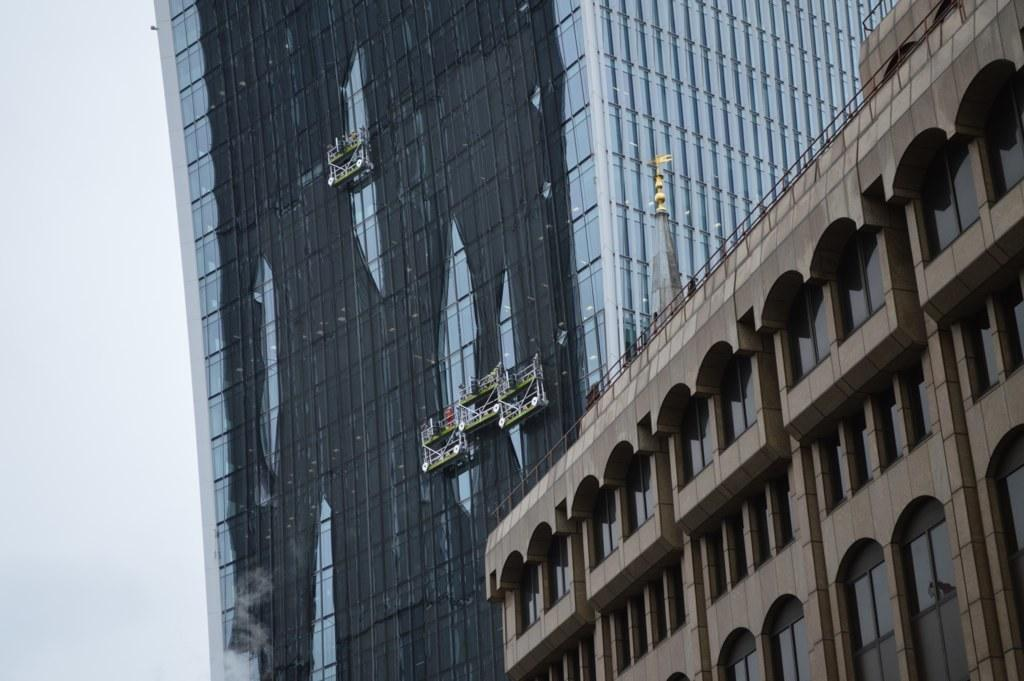What type of structures can be seen in the image? There are buildings in the image. What kind of objects are made of glass in the image? There are glass objects in the image. What architectural features are present in the image? There are walls and railings in the image. What type of clothing can be seen in the image? There are clothes in the image. What other objects are present besides the ones mentioned? There are other objects in the image. What part of the natural environment is visible in the image? The sky is visible on the left side of the image. Where is the toothbrush located in the image? There is no toothbrush present in the image. What is the afterthought of the person who took the picture? We cannot determine the afterthought of the person who took the picture from the image alone. 